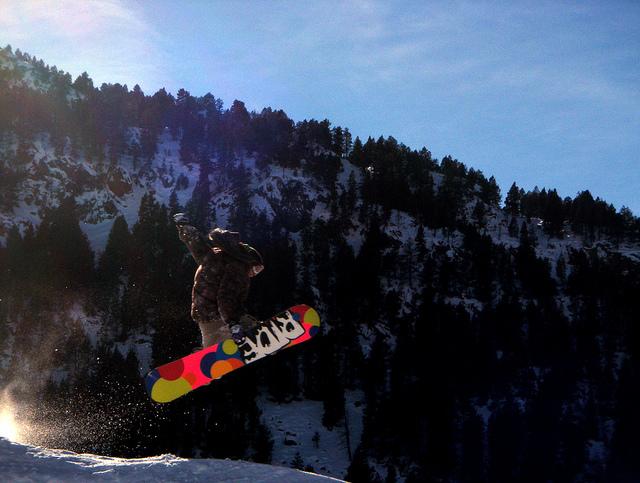What color is the board?
Give a very brief answer. It is yellow, red, blue, and pink. What sport is this man playing?
Answer briefly. Snowboarding. Is he doing a trick?
Give a very brief answer. Yes. Would you ever try this?
Write a very short answer. Yes. What covers the mountains besides snow?
Write a very short answer. Trees. What is the person doing?
Short answer required. Snowboarding. 